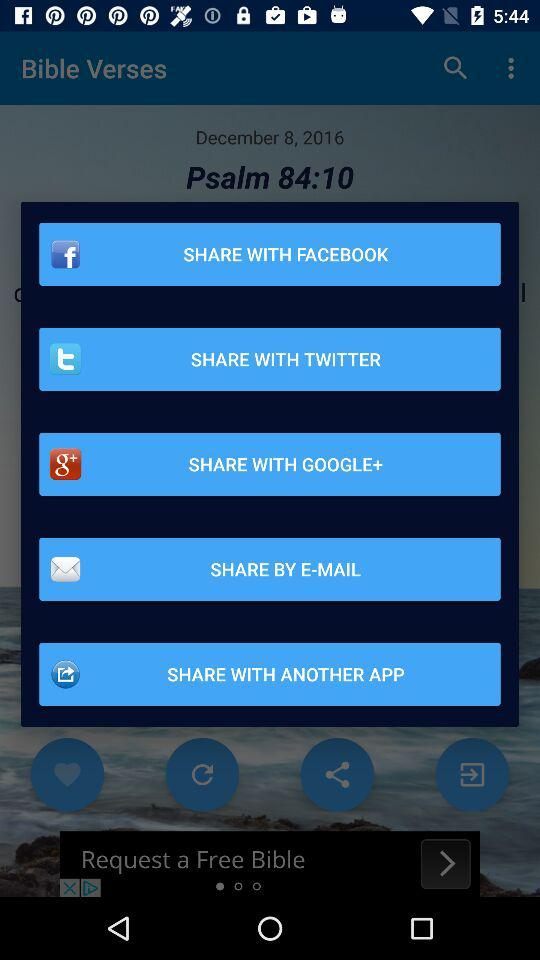What is the chapter number of "Psalm"? The chapter number is 84. 